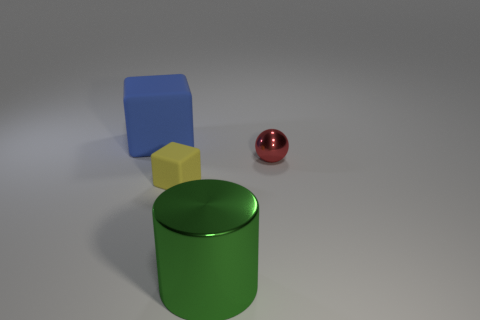What number of matte things are big purple cylinders or cylinders?
Offer a very short reply. 0. There is a block that is to the left of the block that is in front of the object on the right side of the cylinder; what color is it?
Offer a terse response. Blue. What color is the other thing that is the same shape as the large blue rubber object?
Your answer should be very brief. Yellow. Are there any other things that are the same color as the large metallic cylinder?
Offer a very short reply. No. What number of other objects are the same material as the green thing?
Your answer should be very brief. 1. The red metal thing has what size?
Your answer should be compact. Small. Are there any other tiny red shiny objects that have the same shape as the red thing?
Keep it short and to the point. No. What number of things are small red objects or objects on the left side of the metal sphere?
Your answer should be compact. 4. There is a cube in front of the big matte thing; what is its color?
Provide a short and direct response. Yellow. There is a block in front of the big blue cube; does it have the same size as the red shiny sphere that is right of the large blue thing?
Your response must be concise. Yes. 